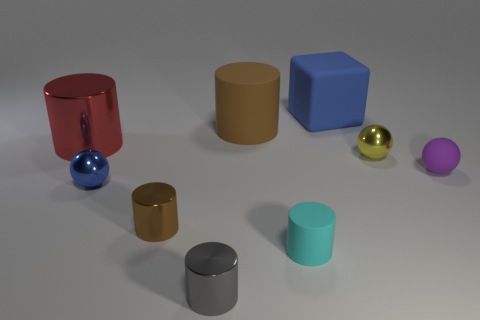There is a tiny purple thing that is the same shape as the blue metal object; what is its material?
Keep it short and to the point. Rubber. There is a matte object that is both behind the yellow metallic thing and in front of the blue cube; what is its size?
Give a very brief answer. Large. What number of blue blocks are the same size as the brown metal cylinder?
Keep it short and to the point. 0. How many yellow things are on the right side of the brown thing behind the brown metal thing?
Your answer should be very brief. 1. Do the rubber cylinder in front of the red metallic thing and the big metallic object have the same color?
Make the answer very short. No. There is a cylinder that is on the left side of the brown cylinder that is in front of the tiny blue metal object; are there any tiny objects on the left side of it?
Provide a succinct answer. No. The matte object that is both in front of the big red shiny cylinder and to the right of the small cyan matte object has what shape?
Ensure brevity in your answer.  Sphere. Is there a large shiny thing of the same color as the rubber sphere?
Give a very brief answer. No. There is a shiny ball that is on the left side of the big rubber thing to the left of the cube; what is its color?
Provide a short and direct response. Blue. What is the size of the brown matte cylinder to the right of the shiny cylinder that is behind the small metal sphere behind the blue shiny sphere?
Give a very brief answer. Large. 